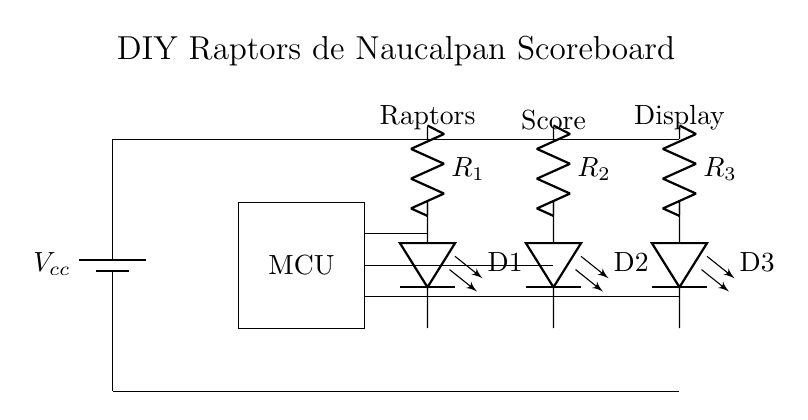What is the main component used to control the LEDs? The main component is the microcontroller, as it processes signals and controls the operation of the LEDs.
Answer: microcontroller How many resistors are in the circuit? The circuit has three resistors, labeled as R1, R2, and R3, which are connected in series to limit the current to the LEDs.
Answer: three What is the purpose of the LEDs in this circuit? The LEDs are used to visually indicate the score of the Raptors de Naucalpan, allowing fans to see the current score at a glance.
Answer: indicate score What is the voltage supply labeled on the diagram? The diagram shows Vcc as the voltage supply, which is typically the power source for the circuit. While the exact voltage is not specified, it is commonly understood to be a standard value like 5V.
Answer: Vcc Which component connects the score display to the power supply? The battery connects the score display to the power supply by providing the necessary voltage for the microcontroller and LEDs to operate.
Answer: battery How are the LEDs connected in relation to the resistors? Each LED is connected in series with its corresponding resistor to ensure that the current flowing through them is limited and does not exceed the LED's maximum rating.
Answer: in series Which label denotes the team associated with the scoreboard? The label "Raptors" above the power supply denotes the team associated with the scoreboard, thus linking the display specifically to the Raptors de Naucalpan.
Answer: Raptors 